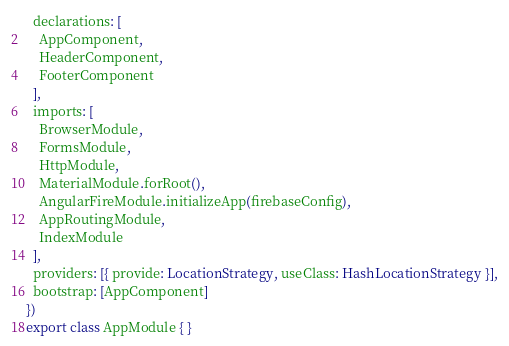Convert code to text. <code><loc_0><loc_0><loc_500><loc_500><_TypeScript_>  declarations: [
    AppComponent,
    HeaderComponent,
    FooterComponent
  ],
  imports: [
    BrowserModule,
    FormsModule,
    HttpModule,
    MaterialModule.forRoot(),
    AngularFireModule.initializeApp(firebaseConfig),
    AppRoutingModule,
    IndexModule
  ],
  providers: [{ provide: LocationStrategy, useClass: HashLocationStrategy }],
  bootstrap: [AppComponent]
})
export class AppModule { }
</code> 